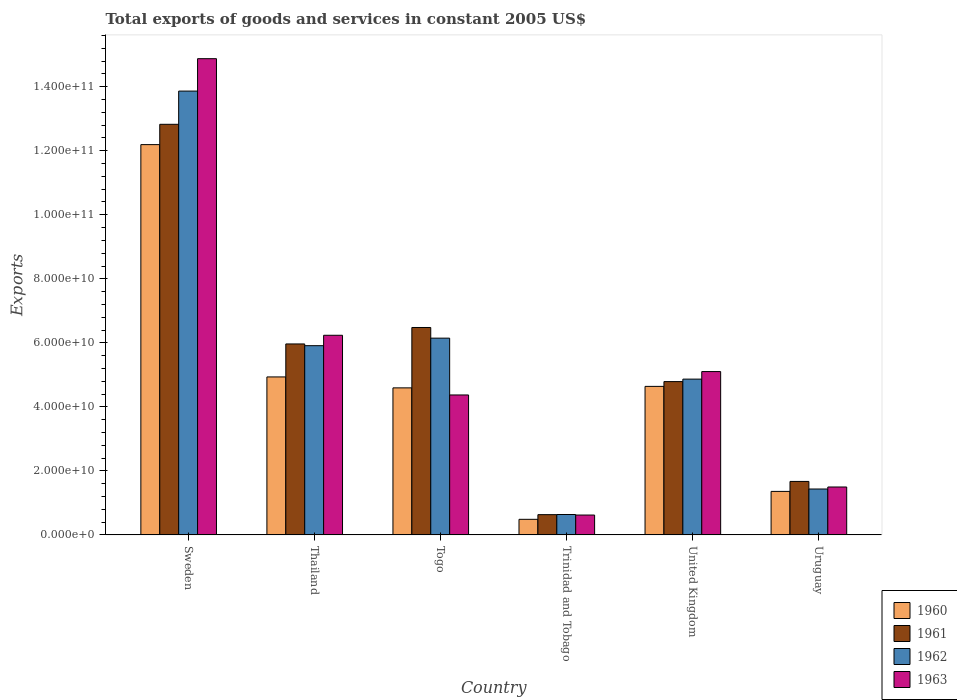How many groups of bars are there?
Offer a terse response. 6. Are the number of bars per tick equal to the number of legend labels?
Make the answer very short. Yes. Are the number of bars on each tick of the X-axis equal?
Make the answer very short. Yes. How many bars are there on the 6th tick from the left?
Provide a succinct answer. 4. What is the label of the 6th group of bars from the left?
Ensure brevity in your answer.  Uruguay. In how many cases, is the number of bars for a given country not equal to the number of legend labels?
Make the answer very short. 0. What is the total exports of goods and services in 1961 in United Kingdom?
Ensure brevity in your answer.  4.79e+1. Across all countries, what is the maximum total exports of goods and services in 1963?
Your answer should be compact. 1.49e+11. Across all countries, what is the minimum total exports of goods and services in 1963?
Offer a terse response. 6.20e+09. In which country was the total exports of goods and services in 1962 minimum?
Your response must be concise. Trinidad and Tobago. What is the total total exports of goods and services in 1962 in the graph?
Offer a terse response. 3.29e+11. What is the difference between the total exports of goods and services in 1960 in Togo and that in Trinidad and Tobago?
Offer a very short reply. 4.11e+1. What is the difference between the total exports of goods and services in 1961 in Sweden and the total exports of goods and services in 1962 in Thailand?
Your answer should be very brief. 6.92e+1. What is the average total exports of goods and services in 1962 per country?
Offer a terse response. 5.48e+1. What is the difference between the total exports of goods and services of/in 1961 and total exports of goods and services of/in 1960 in Sweden?
Your answer should be very brief. 6.34e+09. In how many countries, is the total exports of goods and services in 1962 greater than 144000000000 US$?
Ensure brevity in your answer.  0. What is the ratio of the total exports of goods and services in 1960 in Sweden to that in Trinidad and Tobago?
Ensure brevity in your answer.  25.06. Is the difference between the total exports of goods and services in 1961 in Togo and Uruguay greater than the difference between the total exports of goods and services in 1960 in Togo and Uruguay?
Your answer should be compact. Yes. What is the difference between the highest and the second highest total exports of goods and services in 1962?
Offer a terse response. -7.72e+1. What is the difference between the highest and the lowest total exports of goods and services in 1962?
Give a very brief answer. 1.32e+11. In how many countries, is the total exports of goods and services in 1961 greater than the average total exports of goods and services in 1961 taken over all countries?
Ensure brevity in your answer.  3. Is it the case that in every country, the sum of the total exports of goods and services in 1961 and total exports of goods and services in 1962 is greater than the sum of total exports of goods and services in 1960 and total exports of goods and services in 1963?
Provide a succinct answer. No. What does the 1st bar from the left in Togo represents?
Make the answer very short. 1960. How many bars are there?
Your answer should be compact. 24. Are all the bars in the graph horizontal?
Give a very brief answer. No. Are the values on the major ticks of Y-axis written in scientific E-notation?
Offer a terse response. Yes. Does the graph contain grids?
Your answer should be very brief. No. What is the title of the graph?
Offer a very short reply. Total exports of goods and services in constant 2005 US$. What is the label or title of the X-axis?
Keep it short and to the point. Country. What is the label or title of the Y-axis?
Offer a terse response. Exports. What is the Exports of 1960 in Sweden?
Provide a succinct answer. 1.22e+11. What is the Exports in 1961 in Sweden?
Your response must be concise. 1.28e+11. What is the Exports of 1962 in Sweden?
Your answer should be compact. 1.39e+11. What is the Exports in 1963 in Sweden?
Your answer should be very brief. 1.49e+11. What is the Exports in 1960 in Thailand?
Provide a succinct answer. 4.93e+1. What is the Exports of 1961 in Thailand?
Provide a succinct answer. 5.97e+1. What is the Exports in 1962 in Thailand?
Your response must be concise. 5.91e+1. What is the Exports in 1963 in Thailand?
Your answer should be compact. 6.24e+1. What is the Exports in 1960 in Togo?
Your answer should be very brief. 4.59e+1. What is the Exports in 1961 in Togo?
Offer a terse response. 6.48e+1. What is the Exports of 1962 in Togo?
Ensure brevity in your answer.  6.15e+1. What is the Exports of 1963 in Togo?
Offer a very short reply. 4.37e+1. What is the Exports of 1960 in Trinidad and Tobago?
Ensure brevity in your answer.  4.86e+09. What is the Exports in 1961 in Trinidad and Tobago?
Your answer should be compact. 6.32e+09. What is the Exports in 1962 in Trinidad and Tobago?
Your answer should be very brief. 6.37e+09. What is the Exports in 1963 in Trinidad and Tobago?
Offer a very short reply. 6.20e+09. What is the Exports in 1960 in United Kingdom?
Provide a succinct answer. 4.64e+1. What is the Exports in 1961 in United Kingdom?
Your answer should be compact. 4.79e+1. What is the Exports in 1962 in United Kingdom?
Offer a very short reply. 4.87e+1. What is the Exports of 1963 in United Kingdom?
Offer a very short reply. 5.10e+1. What is the Exports in 1960 in Uruguay?
Offer a very short reply. 1.36e+1. What is the Exports in 1961 in Uruguay?
Keep it short and to the point. 1.67e+1. What is the Exports of 1962 in Uruguay?
Your answer should be very brief. 1.43e+1. What is the Exports in 1963 in Uruguay?
Offer a very short reply. 1.50e+1. Across all countries, what is the maximum Exports of 1960?
Offer a very short reply. 1.22e+11. Across all countries, what is the maximum Exports of 1961?
Offer a terse response. 1.28e+11. Across all countries, what is the maximum Exports in 1962?
Ensure brevity in your answer.  1.39e+11. Across all countries, what is the maximum Exports in 1963?
Give a very brief answer. 1.49e+11. Across all countries, what is the minimum Exports of 1960?
Offer a terse response. 4.86e+09. Across all countries, what is the minimum Exports in 1961?
Provide a succinct answer. 6.32e+09. Across all countries, what is the minimum Exports of 1962?
Give a very brief answer. 6.37e+09. Across all countries, what is the minimum Exports in 1963?
Give a very brief answer. 6.20e+09. What is the total Exports of 1960 in the graph?
Keep it short and to the point. 2.82e+11. What is the total Exports of 1961 in the graph?
Provide a short and direct response. 3.24e+11. What is the total Exports in 1962 in the graph?
Offer a very short reply. 3.29e+11. What is the total Exports of 1963 in the graph?
Offer a terse response. 3.27e+11. What is the difference between the Exports of 1960 in Sweden and that in Thailand?
Provide a short and direct response. 7.26e+1. What is the difference between the Exports of 1961 in Sweden and that in Thailand?
Ensure brevity in your answer.  6.86e+1. What is the difference between the Exports in 1962 in Sweden and that in Thailand?
Keep it short and to the point. 7.95e+1. What is the difference between the Exports in 1963 in Sweden and that in Thailand?
Give a very brief answer. 8.64e+1. What is the difference between the Exports in 1960 in Sweden and that in Togo?
Offer a very short reply. 7.60e+1. What is the difference between the Exports of 1961 in Sweden and that in Togo?
Ensure brevity in your answer.  6.35e+1. What is the difference between the Exports of 1962 in Sweden and that in Togo?
Ensure brevity in your answer.  7.72e+1. What is the difference between the Exports in 1963 in Sweden and that in Togo?
Your answer should be compact. 1.05e+11. What is the difference between the Exports in 1960 in Sweden and that in Trinidad and Tobago?
Offer a terse response. 1.17e+11. What is the difference between the Exports of 1961 in Sweden and that in Trinidad and Tobago?
Your answer should be compact. 1.22e+11. What is the difference between the Exports of 1962 in Sweden and that in Trinidad and Tobago?
Provide a succinct answer. 1.32e+11. What is the difference between the Exports in 1963 in Sweden and that in Trinidad and Tobago?
Your response must be concise. 1.43e+11. What is the difference between the Exports in 1960 in Sweden and that in United Kingdom?
Make the answer very short. 7.55e+1. What is the difference between the Exports in 1961 in Sweden and that in United Kingdom?
Provide a succinct answer. 8.04e+1. What is the difference between the Exports of 1962 in Sweden and that in United Kingdom?
Your answer should be very brief. 9.00e+1. What is the difference between the Exports of 1963 in Sweden and that in United Kingdom?
Your response must be concise. 9.77e+1. What is the difference between the Exports of 1960 in Sweden and that in Uruguay?
Make the answer very short. 1.08e+11. What is the difference between the Exports in 1961 in Sweden and that in Uruguay?
Offer a terse response. 1.12e+11. What is the difference between the Exports in 1962 in Sweden and that in Uruguay?
Provide a short and direct response. 1.24e+11. What is the difference between the Exports in 1963 in Sweden and that in Uruguay?
Make the answer very short. 1.34e+11. What is the difference between the Exports of 1960 in Thailand and that in Togo?
Your response must be concise. 3.42e+09. What is the difference between the Exports of 1961 in Thailand and that in Togo?
Provide a short and direct response. -5.14e+09. What is the difference between the Exports in 1962 in Thailand and that in Togo?
Make the answer very short. -2.36e+09. What is the difference between the Exports of 1963 in Thailand and that in Togo?
Keep it short and to the point. 1.87e+1. What is the difference between the Exports of 1960 in Thailand and that in Trinidad and Tobago?
Keep it short and to the point. 4.45e+1. What is the difference between the Exports of 1961 in Thailand and that in Trinidad and Tobago?
Keep it short and to the point. 5.33e+1. What is the difference between the Exports in 1962 in Thailand and that in Trinidad and Tobago?
Give a very brief answer. 5.27e+1. What is the difference between the Exports of 1963 in Thailand and that in Trinidad and Tobago?
Your answer should be compact. 5.62e+1. What is the difference between the Exports in 1960 in Thailand and that in United Kingdom?
Your answer should be compact. 2.95e+09. What is the difference between the Exports in 1961 in Thailand and that in United Kingdom?
Your answer should be very brief. 1.18e+1. What is the difference between the Exports of 1962 in Thailand and that in United Kingdom?
Provide a succinct answer. 1.04e+1. What is the difference between the Exports in 1963 in Thailand and that in United Kingdom?
Your response must be concise. 1.13e+1. What is the difference between the Exports in 1960 in Thailand and that in Uruguay?
Your answer should be compact. 3.58e+1. What is the difference between the Exports of 1961 in Thailand and that in Uruguay?
Ensure brevity in your answer.  4.30e+1. What is the difference between the Exports of 1962 in Thailand and that in Uruguay?
Ensure brevity in your answer.  4.48e+1. What is the difference between the Exports in 1963 in Thailand and that in Uruguay?
Your answer should be very brief. 4.74e+1. What is the difference between the Exports in 1960 in Togo and that in Trinidad and Tobago?
Your response must be concise. 4.11e+1. What is the difference between the Exports of 1961 in Togo and that in Trinidad and Tobago?
Provide a short and direct response. 5.85e+1. What is the difference between the Exports in 1962 in Togo and that in Trinidad and Tobago?
Offer a terse response. 5.51e+1. What is the difference between the Exports in 1963 in Togo and that in Trinidad and Tobago?
Your response must be concise. 3.75e+1. What is the difference between the Exports of 1960 in Togo and that in United Kingdom?
Your answer should be very brief. -4.64e+08. What is the difference between the Exports of 1961 in Togo and that in United Kingdom?
Give a very brief answer. 1.69e+1. What is the difference between the Exports of 1962 in Togo and that in United Kingdom?
Ensure brevity in your answer.  1.28e+1. What is the difference between the Exports of 1963 in Togo and that in United Kingdom?
Your answer should be compact. -7.31e+09. What is the difference between the Exports in 1960 in Togo and that in Uruguay?
Give a very brief answer. 3.23e+1. What is the difference between the Exports in 1961 in Togo and that in Uruguay?
Provide a succinct answer. 4.81e+1. What is the difference between the Exports of 1962 in Togo and that in Uruguay?
Offer a very short reply. 4.71e+1. What is the difference between the Exports of 1963 in Togo and that in Uruguay?
Offer a very short reply. 2.87e+1. What is the difference between the Exports in 1960 in Trinidad and Tobago and that in United Kingdom?
Your answer should be very brief. -4.15e+1. What is the difference between the Exports of 1961 in Trinidad and Tobago and that in United Kingdom?
Ensure brevity in your answer.  -4.16e+1. What is the difference between the Exports in 1962 in Trinidad and Tobago and that in United Kingdom?
Offer a terse response. -4.23e+1. What is the difference between the Exports of 1963 in Trinidad and Tobago and that in United Kingdom?
Your response must be concise. -4.48e+1. What is the difference between the Exports in 1960 in Trinidad and Tobago and that in Uruguay?
Give a very brief answer. -8.73e+09. What is the difference between the Exports in 1961 in Trinidad and Tobago and that in Uruguay?
Provide a succinct answer. -1.04e+1. What is the difference between the Exports of 1962 in Trinidad and Tobago and that in Uruguay?
Your answer should be compact. -7.97e+09. What is the difference between the Exports in 1963 in Trinidad and Tobago and that in Uruguay?
Your answer should be compact. -8.76e+09. What is the difference between the Exports of 1960 in United Kingdom and that in Uruguay?
Your response must be concise. 3.28e+1. What is the difference between the Exports in 1961 in United Kingdom and that in Uruguay?
Make the answer very short. 3.12e+1. What is the difference between the Exports in 1962 in United Kingdom and that in Uruguay?
Your answer should be very brief. 3.43e+1. What is the difference between the Exports of 1963 in United Kingdom and that in Uruguay?
Provide a short and direct response. 3.61e+1. What is the difference between the Exports in 1960 in Sweden and the Exports in 1961 in Thailand?
Offer a very short reply. 6.23e+1. What is the difference between the Exports of 1960 in Sweden and the Exports of 1962 in Thailand?
Your response must be concise. 6.28e+1. What is the difference between the Exports of 1960 in Sweden and the Exports of 1963 in Thailand?
Give a very brief answer. 5.96e+1. What is the difference between the Exports in 1961 in Sweden and the Exports in 1962 in Thailand?
Your answer should be very brief. 6.92e+1. What is the difference between the Exports of 1961 in Sweden and the Exports of 1963 in Thailand?
Offer a terse response. 6.59e+1. What is the difference between the Exports in 1962 in Sweden and the Exports in 1963 in Thailand?
Your response must be concise. 7.63e+1. What is the difference between the Exports in 1960 in Sweden and the Exports in 1961 in Togo?
Offer a terse response. 5.71e+1. What is the difference between the Exports in 1960 in Sweden and the Exports in 1962 in Togo?
Ensure brevity in your answer.  6.05e+1. What is the difference between the Exports in 1960 in Sweden and the Exports in 1963 in Togo?
Your answer should be very brief. 7.82e+1. What is the difference between the Exports of 1961 in Sweden and the Exports of 1962 in Togo?
Make the answer very short. 6.68e+1. What is the difference between the Exports of 1961 in Sweden and the Exports of 1963 in Togo?
Provide a succinct answer. 8.46e+1. What is the difference between the Exports in 1962 in Sweden and the Exports in 1963 in Togo?
Offer a terse response. 9.49e+1. What is the difference between the Exports of 1960 in Sweden and the Exports of 1961 in Trinidad and Tobago?
Keep it short and to the point. 1.16e+11. What is the difference between the Exports in 1960 in Sweden and the Exports in 1962 in Trinidad and Tobago?
Make the answer very short. 1.16e+11. What is the difference between the Exports of 1960 in Sweden and the Exports of 1963 in Trinidad and Tobago?
Your answer should be very brief. 1.16e+11. What is the difference between the Exports in 1961 in Sweden and the Exports in 1962 in Trinidad and Tobago?
Offer a very short reply. 1.22e+11. What is the difference between the Exports in 1961 in Sweden and the Exports in 1963 in Trinidad and Tobago?
Ensure brevity in your answer.  1.22e+11. What is the difference between the Exports in 1962 in Sweden and the Exports in 1963 in Trinidad and Tobago?
Your answer should be compact. 1.32e+11. What is the difference between the Exports of 1960 in Sweden and the Exports of 1961 in United Kingdom?
Provide a succinct answer. 7.40e+1. What is the difference between the Exports of 1960 in Sweden and the Exports of 1962 in United Kingdom?
Your answer should be compact. 7.33e+1. What is the difference between the Exports of 1960 in Sweden and the Exports of 1963 in United Kingdom?
Offer a very short reply. 7.09e+1. What is the difference between the Exports in 1961 in Sweden and the Exports in 1962 in United Kingdom?
Give a very brief answer. 7.96e+1. What is the difference between the Exports in 1961 in Sweden and the Exports in 1963 in United Kingdom?
Your answer should be very brief. 7.72e+1. What is the difference between the Exports of 1962 in Sweden and the Exports of 1963 in United Kingdom?
Ensure brevity in your answer.  8.76e+1. What is the difference between the Exports of 1960 in Sweden and the Exports of 1961 in Uruguay?
Your answer should be very brief. 1.05e+11. What is the difference between the Exports of 1960 in Sweden and the Exports of 1962 in Uruguay?
Your answer should be very brief. 1.08e+11. What is the difference between the Exports in 1960 in Sweden and the Exports in 1963 in Uruguay?
Ensure brevity in your answer.  1.07e+11. What is the difference between the Exports of 1961 in Sweden and the Exports of 1962 in Uruguay?
Your answer should be very brief. 1.14e+11. What is the difference between the Exports in 1961 in Sweden and the Exports in 1963 in Uruguay?
Ensure brevity in your answer.  1.13e+11. What is the difference between the Exports of 1962 in Sweden and the Exports of 1963 in Uruguay?
Offer a terse response. 1.24e+11. What is the difference between the Exports of 1960 in Thailand and the Exports of 1961 in Togo?
Your answer should be compact. -1.54e+1. What is the difference between the Exports in 1960 in Thailand and the Exports in 1962 in Togo?
Offer a very short reply. -1.21e+1. What is the difference between the Exports in 1960 in Thailand and the Exports in 1963 in Togo?
Provide a short and direct response. 5.64e+09. What is the difference between the Exports in 1961 in Thailand and the Exports in 1962 in Togo?
Keep it short and to the point. -1.81e+09. What is the difference between the Exports in 1961 in Thailand and the Exports in 1963 in Togo?
Your answer should be compact. 1.59e+1. What is the difference between the Exports of 1962 in Thailand and the Exports of 1963 in Togo?
Give a very brief answer. 1.54e+1. What is the difference between the Exports in 1960 in Thailand and the Exports in 1961 in Trinidad and Tobago?
Give a very brief answer. 4.30e+1. What is the difference between the Exports in 1960 in Thailand and the Exports in 1962 in Trinidad and Tobago?
Your response must be concise. 4.30e+1. What is the difference between the Exports of 1960 in Thailand and the Exports of 1963 in Trinidad and Tobago?
Your answer should be very brief. 4.31e+1. What is the difference between the Exports of 1961 in Thailand and the Exports of 1962 in Trinidad and Tobago?
Your answer should be compact. 5.33e+1. What is the difference between the Exports in 1961 in Thailand and the Exports in 1963 in Trinidad and Tobago?
Offer a very short reply. 5.34e+1. What is the difference between the Exports in 1962 in Thailand and the Exports in 1963 in Trinidad and Tobago?
Provide a short and direct response. 5.29e+1. What is the difference between the Exports in 1960 in Thailand and the Exports in 1961 in United Kingdom?
Your answer should be compact. 1.46e+09. What is the difference between the Exports in 1960 in Thailand and the Exports in 1962 in United Kingdom?
Keep it short and to the point. 6.85e+08. What is the difference between the Exports of 1960 in Thailand and the Exports of 1963 in United Kingdom?
Keep it short and to the point. -1.67e+09. What is the difference between the Exports of 1961 in Thailand and the Exports of 1962 in United Kingdom?
Your answer should be very brief. 1.10e+1. What is the difference between the Exports in 1961 in Thailand and the Exports in 1963 in United Kingdom?
Offer a terse response. 8.63e+09. What is the difference between the Exports of 1962 in Thailand and the Exports of 1963 in United Kingdom?
Your answer should be very brief. 8.09e+09. What is the difference between the Exports of 1960 in Thailand and the Exports of 1961 in Uruguay?
Offer a terse response. 3.26e+1. What is the difference between the Exports in 1960 in Thailand and the Exports in 1962 in Uruguay?
Keep it short and to the point. 3.50e+1. What is the difference between the Exports of 1960 in Thailand and the Exports of 1963 in Uruguay?
Offer a very short reply. 3.44e+1. What is the difference between the Exports in 1961 in Thailand and the Exports in 1962 in Uruguay?
Your answer should be compact. 4.53e+1. What is the difference between the Exports of 1961 in Thailand and the Exports of 1963 in Uruguay?
Keep it short and to the point. 4.47e+1. What is the difference between the Exports in 1962 in Thailand and the Exports in 1963 in Uruguay?
Give a very brief answer. 4.41e+1. What is the difference between the Exports in 1960 in Togo and the Exports in 1961 in Trinidad and Tobago?
Offer a terse response. 3.96e+1. What is the difference between the Exports of 1960 in Togo and the Exports of 1962 in Trinidad and Tobago?
Your response must be concise. 3.96e+1. What is the difference between the Exports in 1960 in Togo and the Exports in 1963 in Trinidad and Tobago?
Your response must be concise. 3.97e+1. What is the difference between the Exports in 1961 in Togo and the Exports in 1962 in Trinidad and Tobago?
Provide a succinct answer. 5.84e+1. What is the difference between the Exports in 1961 in Togo and the Exports in 1963 in Trinidad and Tobago?
Provide a short and direct response. 5.86e+1. What is the difference between the Exports of 1962 in Togo and the Exports of 1963 in Trinidad and Tobago?
Offer a very short reply. 5.53e+1. What is the difference between the Exports in 1960 in Togo and the Exports in 1961 in United Kingdom?
Make the answer very short. -1.96e+09. What is the difference between the Exports in 1960 in Togo and the Exports in 1962 in United Kingdom?
Your response must be concise. -2.73e+09. What is the difference between the Exports of 1960 in Togo and the Exports of 1963 in United Kingdom?
Provide a short and direct response. -5.09e+09. What is the difference between the Exports in 1961 in Togo and the Exports in 1962 in United Kingdom?
Give a very brief answer. 1.61e+1. What is the difference between the Exports of 1961 in Togo and the Exports of 1963 in United Kingdom?
Offer a terse response. 1.38e+1. What is the difference between the Exports in 1962 in Togo and the Exports in 1963 in United Kingdom?
Ensure brevity in your answer.  1.04e+1. What is the difference between the Exports in 1960 in Togo and the Exports in 1961 in Uruguay?
Make the answer very short. 2.92e+1. What is the difference between the Exports in 1960 in Togo and the Exports in 1962 in Uruguay?
Offer a terse response. 3.16e+1. What is the difference between the Exports in 1960 in Togo and the Exports in 1963 in Uruguay?
Your answer should be very brief. 3.10e+1. What is the difference between the Exports in 1961 in Togo and the Exports in 1962 in Uruguay?
Your answer should be very brief. 5.05e+1. What is the difference between the Exports of 1961 in Togo and the Exports of 1963 in Uruguay?
Provide a short and direct response. 4.98e+1. What is the difference between the Exports of 1962 in Togo and the Exports of 1963 in Uruguay?
Provide a short and direct response. 4.65e+1. What is the difference between the Exports in 1960 in Trinidad and Tobago and the Exports in 1961 in United Kingdom?
Make the answer very short. -4.30e+1. What is the difference between the Exports of 1960 in Trinidad and Tobago and the Exports of 1962 in United Kingdom?
Keep it short and to the point. -4.38e+1. What is the difference between the Exports in 1960 in Trinidad and Tobago and the Exports in 1963 in United Kingdom?
Your answer should be very brief. -4.62e+1. What is the difference between the Exports of 1961 in Trinidad and Tobago and the Exports of 1962 in United Kingdom?
Your answer should be very brief. -4.23e+1. What is the difference between the Exports in 1961 in Trinidad and Tobago and the Exports in 1963 in United Kingdom?
Your answer should be very brief. -4.47e+1. What is the difference between the Exports of 1962 in Trinidad and Tobago and the Exports of 1963 in United Kingdom?
Ensure brevity in your answer.  -4.47e+1. What is the difference between the Exports in 1960 in Trinidad and Tobago and the Exports in 1961 in Uruguay?
Your answer should be compact. -1.18e+1. What is the difference between the Exports of 1960 in Trinidad and Tobago and the Exports of 1962 in Uruguay?
Offer a very short reply. -9.47e+09. What is the difference between the Exports of 1960 in Trinidad and Tobago and the Exports of 1963 in Uruguay?
Make the answer very short. -1.01e+1. What is the difference between the Exports in 1961 in Trinidad and Tobago and the Exports in 1962 in Uruguay?
Keep it short and to the point. -8.01e+09. What is the difference between the Exports of 1961 in Trinidad and Tobago and the Exports of 1963 in Uruguay?
Keep it short and to the point. -8.64e+09. What is the difference between the Exports in 1962 in Trinidad and Tobago and the Exports in 1963 in Uruguay?
Give a very brief answer. -8.59e+09. What is the difference between the Exports of 1960 in United Kingdom and the Exports of 1961 in Uruguay?
Provide a succinct answer. 2.97e+1. What is the difference between the Exports of 1960 in United Kingdom and the Exports of 1962 in Uruguay?
Make the answer very short. 3.21e+1. What is the difference between the Exports in 1960 in United Kingdom and the Exports in 1963 in Uruguay?
Your answer should be compact. 3.14e+1. What is the difference between the Exports in 1961 in United Kingdom and the Exports in 1962 in Uruguay?
Offer a terse response. 3.36e+1. What is the difference between the Exports in 1961 in United Kingdom and the Exports in 1963 in Uruguay?
Offer a terse response. 3.29e+1. What is the difference between the Exports in 1962 in United Kingdom and the Exports in 1963 in Uruguay?
Provide a short and direct response. 3.37e+1. What is the average Exports in 1960 per country?
Give a very brief answer. 4.70e+1. What is the average Exports in 1961 per country?
Give a very brief answer. 5.39e+1. What is the average Exports in 1962 per country?
Make the answer very short. 5.48e+1. What is the average Exports of 1963 per country?
Make the answer very short. 5.45e+1. What is the difference between the Exports of 1960 and Exports of 1961 in Sweden?
Offer a very short reply. -6.34e+09. What is the difference between the Exports of 1960 and Exports of 1962 in Sweden?
Keep it short and to the point. -1.67e+1. What is the difference between the Exports of 1960 and Exports of 1963 in Sweden?
Keep it short and to the point. -2.68e+1. What is the difference between the Exports of 1961 and Exports of 1962 in Sweden?
Provide a short and direct response. -1.04e+1. What is the difference between the Exports in 1961 and Exports in 1963 in Sweden?
Your response must be concise. -2.05e+1. What is the difference between the Exports of 1962 and Exports of 1963 in Sweden?
Keep it short and to the point. -1.01e+1. What is the difference between the Exports in 1960 and Exports in 1961 in Thailand?
Keep it short and to the point. -1.03e+1. What is the difference between the Exports in 1960 and Exports in 1962 in Thailand?
Your response must be concise. -9.76e+09. What is the difference between the Exports of 1960 and Exports of 1963 in Thailand?
Offer a very short reply. -1.30e+1. What is the difference between the Exports in 1961 and Exports in 1962 in Thailand?
Offer a terse response. 5.43e+08. What is the difference between the Exports in 1961 and Exports in 1963 in Thailand?
Give a very brief answer. -2.71e+09. What is the difference between the Exports in 1962 and Exports in 1963 in Thailand?
Your answer should be compact. -3.25e+09. What is the difference between the Exports of 1960 and Exports of 1961 in Togo?
Offer a terse response. -1.89e+1. What is the difference between the Exports of 1960 and Exports of 1962 in Togo?
Your answer should be compact. -1.55e+1. What is the difference between the Exports in 1960 and Exports in 1963 in Togo?
Your answer should be compact. 2.22e+09. What is the difference between the Exports in 1961 and Exports in 1962 in Togo?
Provide a short and direct response. 3.33e+09. What is the difference between the Exports of 1961 and Exports of 1963 in Togo?
Offer a terse response. 2.11e+1. What is the difference between the Exports in 1962 and Exports in 1963 in Togo?
Your response must be concise. 1.78e+1. What is the difference between the Exports of 1960 and Exports of 1961 in Trinidad and Tobago?
Give a very brief answer. -1.46e+09. What is the difference between the Exports of 1960 and Exports of 1962 in Trinidad and Tobago?
Your answer should be compact. -1.51e+09. What is the difference between the Exports in 1960 and Exports in 1963 in Trinidad and Tobago?
Provide a short and direct response. -1.34e+09. What is the difference between the Exports of 1961 and Exports of 1962 in Trinidad and Tobago?
Give a very brief answer. -4.56e+07. What is the difference between the Exports in 1961 and Exports in 1963 in Trinidad and Tobago?
Make the answer very short. 1.22e+08. What is the difference between the Exports in 1962 and Exports in 1963 in Trinidad and Tobago?
Your answer should be compact. 1.67e+08. What is the difference between the Exports of 1960 and Exports of 1961 in United Kingdom?
Give a very brief answer. -1.49e+09. What is the difference between the Exports of 1960 and Exports of 1962 in United Kingdom?
Your response must be concise. -2.27e+09. What is the difference between the Exports of 1960 and Exports of 1963 in United Kingdom?
Give a very brief answer. -4.63e+09. What is the difference between the Exports of 1961 and Exports of 1962 in United Kingdom?
Make the answer very short. -7.73e+08. What is the difference between the Exports of 1961 and Exports of 1963 in United Kingdom?
Give a very brief answer. -3.13e+09. What is the difference between the Exports in 1962 and Exports in 1963 in United Kingdom?
Your response must be concise. -2.36e+09. What is the difference between the Exports in 1960 and Exports in 1961 in Uruguay?
Your answer should be very brief. -3.11e+09. What is the difference between the Exports of 1960 and Exports of 1962 in Uruguay?
Offer a very short reply. -7.48e+08. What is the difference between the Exports in 1960 and Exports in 1963 in Uruguay?
Your response must be concise. -1.37e+09. What is the difference between the Exports of 1961 and Exports of 1962 in Uruguay?
Your answer should be compact. 2.36e+09. What is the difference between the Exports of 1961 and Exports of 1963 in Uruguay?
Your answer should be compact. 1.74e+09. What is the difference between the Exports in 1962 and Exports in 1963 in Uruguay?
Give a very brief answer. -6.27e+08. What is the ratio of the Exports in 1960 in Sweden to that in Thailand?
Keep it short and to the point. 2.47. What is the ratio of the Exports in 1961 in Sweden to that in Thailand?
Offer a terse response. 2.15. What is the ratio of the Exports in 1962 in Sweden to that in Thailand?
Provide a short and direct response. 2.35. What is the ratio of the Exports of 1963 in Sweden to that in Thailand?
Offer a very short reply. 2.39. What is the ratio of the Exports of 1960 in Sweden to that in Togo?
Provide a succinct answer. 2.65. What is the ratio of the Exports of 1961 in Sweden to that in Togo?
Your answer should be very brief. 1.98. What is the ratio of the Exports in 1962 in Sweden to that in Togo?
Offer a terse response. 2.26. What is the ratio of the Exports in 1963 in Sweden to that in Togo?
Your answer should be very brief. 3.4. What is the ratio of the Exports in 1960 in Sweden to that in Trinidad and Tobago?
Ensure brevity in your answer.  25.06. What is the ratio of the Exports of 1961 in Sweden to that in Trinidad and Tobago?
Your response must be concise. 20.28. What is the ratio of the Exports of 1962 in Sweden to that in Trinidad and Tobago?
Your answer should be very brief. 21.77. What is the ratio of the Exports in 1963 in Sweden to that in Trinidad and Tobago?
Make the answer very short. 23.98. What is the ratio of the Exports in 1960 in Sweden to that in United Kingdom?
Offer a very short reply. 2.63. What is the ratio of the Exports in 1961 in Sweden to that in United Kingdom?
Provide a short and direct response. 2.68. What is the ratio of the Exports of 1962 in Sweden to that in United Kingdom?
Your answer should be very brief. 2.85. What is the ratio of the Exports of 1963 in Sweden to that in United Kingdom?
Provide a succinct answer. 2.92. What is the ratio of the Exports of 1960 in Sweden to that in Uruguay?
Provide a short and direct response. 8.97. What is the ratio of the Exports in 1961 in Sweden to that in Uruguay?
Your response must be concise. 7.68. What is the ratio of the Exports in 1962 in Sweden to that in Uruguay?
Offer a very short reply. 9.67. What is the ratio of the Exports in 1963 in Sweden to that in Uruguay?
Make the answer very short. 9.94. What is the ratio of the Exports of 1960 in Thailand to that in Togo?
Offer a very short reply. 1.07. What is the ratio of the Exports in 1961 in Thailand to that in Togo?
Your answer should be compact. 0.92. What is the ratio of the Exports in 1962 in Thailand to that in Togo?
Provide a succinct answer. 0.96. What is the ratio of the Exports of 1963 in Thailand to that in Togo?
Give a very brief answer. 1.43. What is the ratio of the Exports in 1960 in Thailand to that in Trinidad and Tobago?
Offer a terse response. 10.14. What is the ratio of the Exports in 1961 in Thailand to that in Trinidad and Tobago?
Your answer should be very brief. 9.43. What is the ratio of the Exports of 1962 in Thailand to that in Trinidad and Tobago?
Make the answer very short. 9.28. What is the ratio of the Exports of 1963 in Thailand to that in Trinidad and Tobago?
Your response must be concise. 10.05. What is the ratio of the Exports of 1960 in Thailand to that in United Kingdom?
Provide a succinct answer. 1.06. What is the ratio of the Exports of 1961 in Thailand to that in United Kingdom?
Your answer should be very brief. 1.25. What is the ratio of the Exports of 1962 in Thailand to that in United Kingdom?
Offer a terse response. 1.21. What is the ratio of the Exports of 1963 in Thailand to that in United Kingdom?
Your response must be concise. 1.22. What is the ratio of the Exports of 1960 in Thailand to that in Uruguay?
Ensure brevity in your answer.  3.63. What is the ratio of the Exports in 1961 in Thailand to that in Uruguay?
Ensure brevity in your answer.  3.57. What is the ratio of the Exports of 1962 in Thailand to that in Uruguay?
Your answer should be very brief. 4.12. What is the ratio of the Exports of 1963 in Thailand to that in Uruguay?
Ensure brevity in your answer.  4.17. What is the ratio of the Exports of 1960 in Togo to that in Trinidad and Tobago?
Make the answer very short. 9.44. What is the ratio of the Exports of 1961 in Togo to that in Trinidad and Tobago?
Your response must be concise. 10.25. What is the ratio of the Exports in 1962 in Togo to that in Trinidad and Tobago?
Provide a short and direct response. 9.65. What is the ratio of the Exports in 1963 in Togo to that in Trinidad and Tobago?
Make the answer very short. 7.05. What is the ratio of the Exports in 1960 in Togo to that in United Kingdom?
Offer a terse response. 0.99. What is the ratio of the Exports of 1961 in Togo to that in United Kingdom?
Your answer should be very brief. 1.35. What is the ratio of the Exports of 1962 in Togo to that in United Kingdom?
Keep it short and to the point. 1.26. What is the ratio of the Exports of 1963 in Togo to that in United Kingdom?
Offer a terse response. 0.86. What is the ratio of the Exports in 1960 in Togo to that in Uruguay?
Keep it short and to the point. 3.38. What is the ratio of the Exports of 1961 in Togo to that in Uruguay?
Your answer should be very brief. 3.88. What is the ratio of the Exports in 1962 in Togo to that in Uruguay?
Your response must be concise. 4.29. What is the ratio of the Exports in 1963 in Togo to that in Uruguay?
Offer a very short reply. 2.92. What is the ratio of the Exports in 1960 in Trinidad and Tobago to that in United Kingdom?
Keep it short and to the point. 0.1. What is the ratio of the Exports of 1961 in Trinidad and Tobago to that in United Kingdom?
Ensure brevity in your answer.  0.13. What is the ratio of the Exports in 1962 in Trinidad and Tobago to that in United Kingdom?
Offer a very short reply. 0.13. What is the ratio of the Exports in 1963 in Trinidad and Tobago to that in United Kingdom?
Offer a terse response. 0.12. What is the ratio of the Exports of 1960 in Trinidad and Tobago to that in Uruguay?
Make the answer very short. 0.36. What is the ratio of the Exports of 1961 in Trinidad and Tobago to that in Uruguay?
Give a very brief answer. 0.38. What is the ratio of the Exports of 1962 in Trinidad and Tobago to that in Uruguay?
Provide a succinct answer. 0.44. What is the ratio of the Exports in 1963 in Trinidad and Tobago to that in Uruguay?
Give a very brief answer. 0.41. What is the ratio of the Exports of 1960 in United Kingdom to that in Uruguay?
Ensure brevity in your answer.  3.41. What is the ratio of the Exports in 1961 in United Kingdom to that in Uruguay?
Offer a very short reply. 2.87. What is the ratio of the Exports in 1962 in United Kingdom to that in Uruguay?
Ensure brevity in your answer.  3.39. What is the ratio of the Exports in 1963 in United Kingdom to that in Uruguay?
Make the answer very short. 3.41. What is the difference between the highest and the second highest Exports of 1960?
Make the answer very short. 7.26e+1. What is the difference between the highest and the second highest Exports in 1961?
Keep it short and to the point. 6.35e+1. What is the difference between the highest and the second highest Exports in 1962?
Ensure brevity in your answer.  7.72e+1. What is the difference between the highest and the second highest Exports in 1963?
Your response must be concise. 8.64e+1. What is the difference between the highest and the lowest Exports in 1960?
Your answer should be very brief. 1.17e+11. What is the difference between the highest and the lowest Exports in 1961?
Make the answer very short. 1.22e+11. What is the difference between the highest and the lowest Exports of 1962?
Provide a succinct answer. 1.32e+11. What is the difference between the highest and the lowest Exports in 1963?
Your response must be concise. 1.43e+11. 